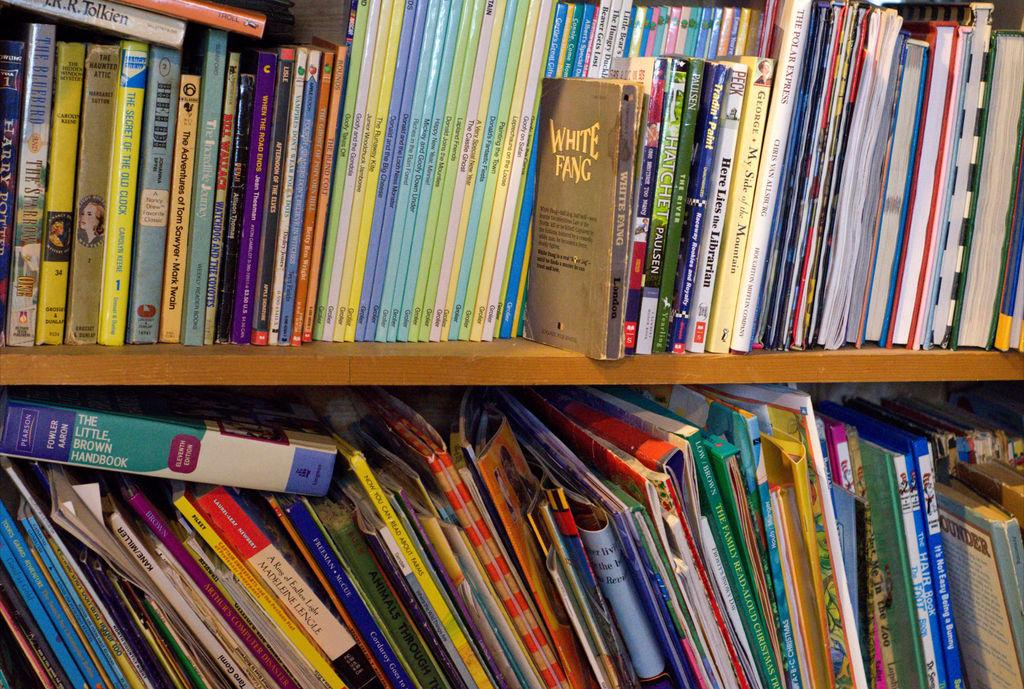Provide a one-sentence caption for the provided image. A bookshelf over flowing with books from early readers to chapter books. 